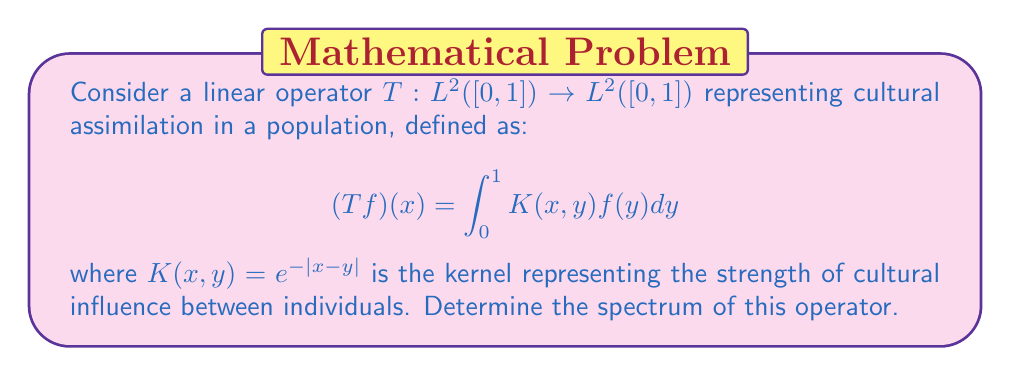Can you answer this question? To determine the spectrum of the linear operator $T$, we need to follow these steps:

1) First, we recognize that $T$ is a compact operator on $L^2([0,1])$ because it is an integral operator with a continuous kernel.

2) For compact operators, the spectrum consists of 0 and the eigenvalues of the operator. So, we need to find the eigenvalues.

3) The eigenvalue equation is:

   $$(Tf)(x) = \lambda f(x)$$

   Which expands to:

   $$\int_0^1 e^{-|x-y|}f(y)dy = \lambda f(x)$$

4) To solve this, we differentiate both sides twice with respect to $x$:

   $$\frac{d^2}{dx^2}\int_0^1 e^{-|x-y|}f(y)dy = \lambda \frac{d^2f}{dx^2}$$

5) The left side simplifies to:

   $$\int_0^1 e^{-|x-y|}f(y)dy - 2f(x) = \lambda \frac{d^2f}{dx^2}$$

6) Combining this with the original equation:

   $$\lambda f(x) - 2f(x) = \lambda \frac{d^2f}{dx^2}$$

7) This simplifies to:

   $$f''(x) + \frac{2-\lambda}{\lambda}f(x) = 0$$

8) This is a second-order differential equation with general solution:

   $$f(x) = A\cos(\omega x) + B\sin(\omega x)$$

   where $\omega^2 = \frac{2-\lambda}{\lambda}$

9) Applying the boundary conditions $f'(0) = f'(1) = 0$ (which come from the original integral equation), we get:

   $$B = 0$$ and $$\omega = n\pi$$ for $n = 0, 1, 2, ...$

10) Substituting back, we get the eigenvalues:

    $$\lambda_n = \frac{2}{1 + (n\pi)^2}$$ for $n = 0, 1, 2, ...$

Therefore, the spectrum of $T$ consists of these eigenvalues and 0 (as the limit point of the sequence of eigenvalues).
Answer: The spectrum of the operator $T$ is:

$$\sigma(T) = \{0\} \cup \{\frac{2}{1 + (n\pi)^2} : n = 0, 1, 2, ...\}$$ 